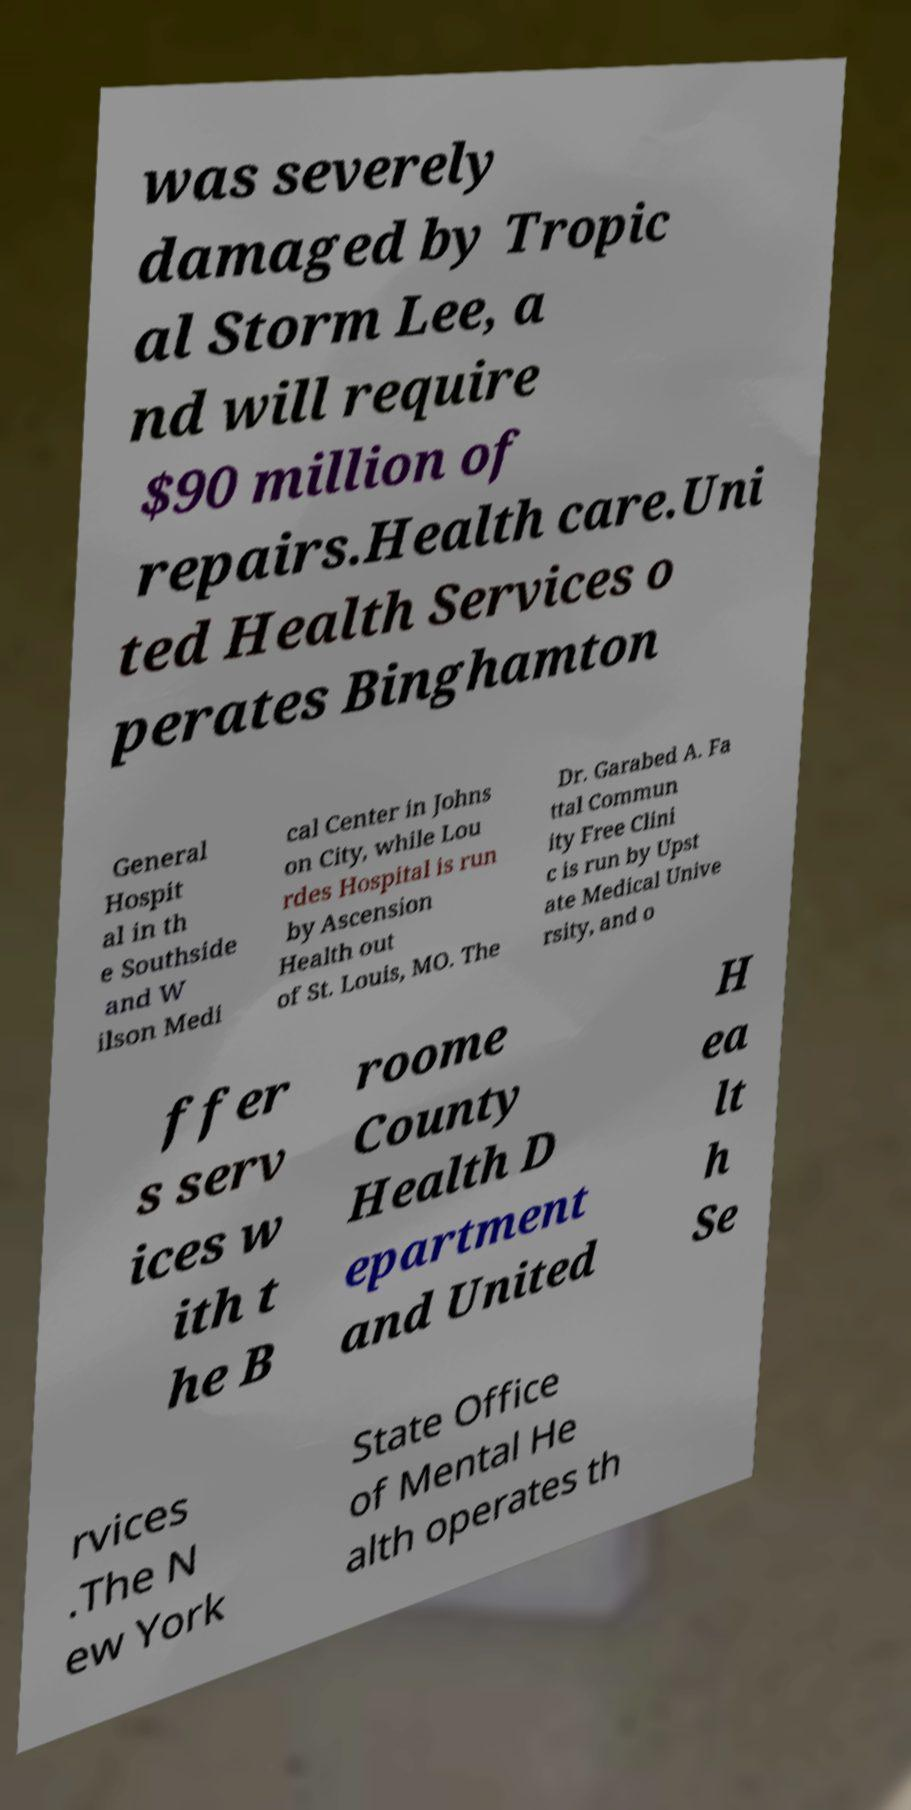I need the written content from this picture converted into text. Can you do that? was severely damaged by Tropic al Storm Lee, a nd will require $90 million of repairs.Health care.Uni ted Health Services o perates Binghamton General Hospit al in th e Southside and W ilson Medi cal Center in Johns on City, while Lou rdes Hospital is run by Ascension Health out of St. Louis, MO. The Dr. Garabed A. Fa ttal Commun ity Free Clini c is run by Upst ate Medical Unive rsity, and o ffer s serv ices w ith t he B roome County Health D epartment and United H ea lt h Se rvices .The N ew York State Office of Mental He alth operates th 